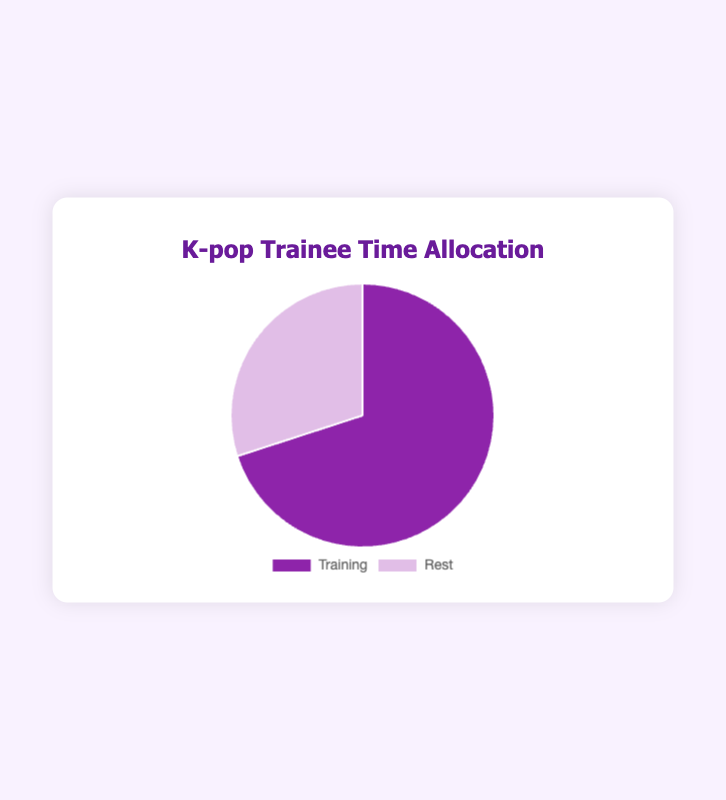How much time is allocated to training? The pie chart shows the percentage of time allocation between training and rest. The slice representing training is labeled with its percentage.
Answer: 70% What's the difference between the time allocated to training and rest? To find the difference, subtract the rest percentage from the training percentage. Use the numbers from the chart: 70% (training) - 30% (rest).
Answer: 40% Do trainees spend more time training or resting? Compare the size of the slices representing training and rest. The slice for training is larger and has a higher percentage.
Answer: Training Which category has the smaller proportion of time allocation? Visually identify the smaller slice by comparing the areas of the chart slices. The rest slice is smaller than the training slice.
Answer: Rest What fraction of time is spent on rest compared to the total time? The fraction is the rest percentage over the total 100%. Given rest is 30%, the fraction is 30/100.
Answer: 3/10 How many times larger is the training time compared to the rest time? Divide the training percentage by the rest percentage. Using the chart: 70% / 30% = 2.333.
Answer: 2.33 times What's the ratio of training to rest time allocation? The ratio of training to rest is their respective percentages divided by each other. From the chart: 70% training to 30% rest gives a ratio of 70:30, which simplifies to 7:3.
Answer: 7:3 If the total time allocated is 10 hours, how many hours are spent on training? Calculate the hours spent on training by multiplying the total hours by the training percentage (70%). Using 10 hours total: 10 * 0.70.
Answer: 7 hours 